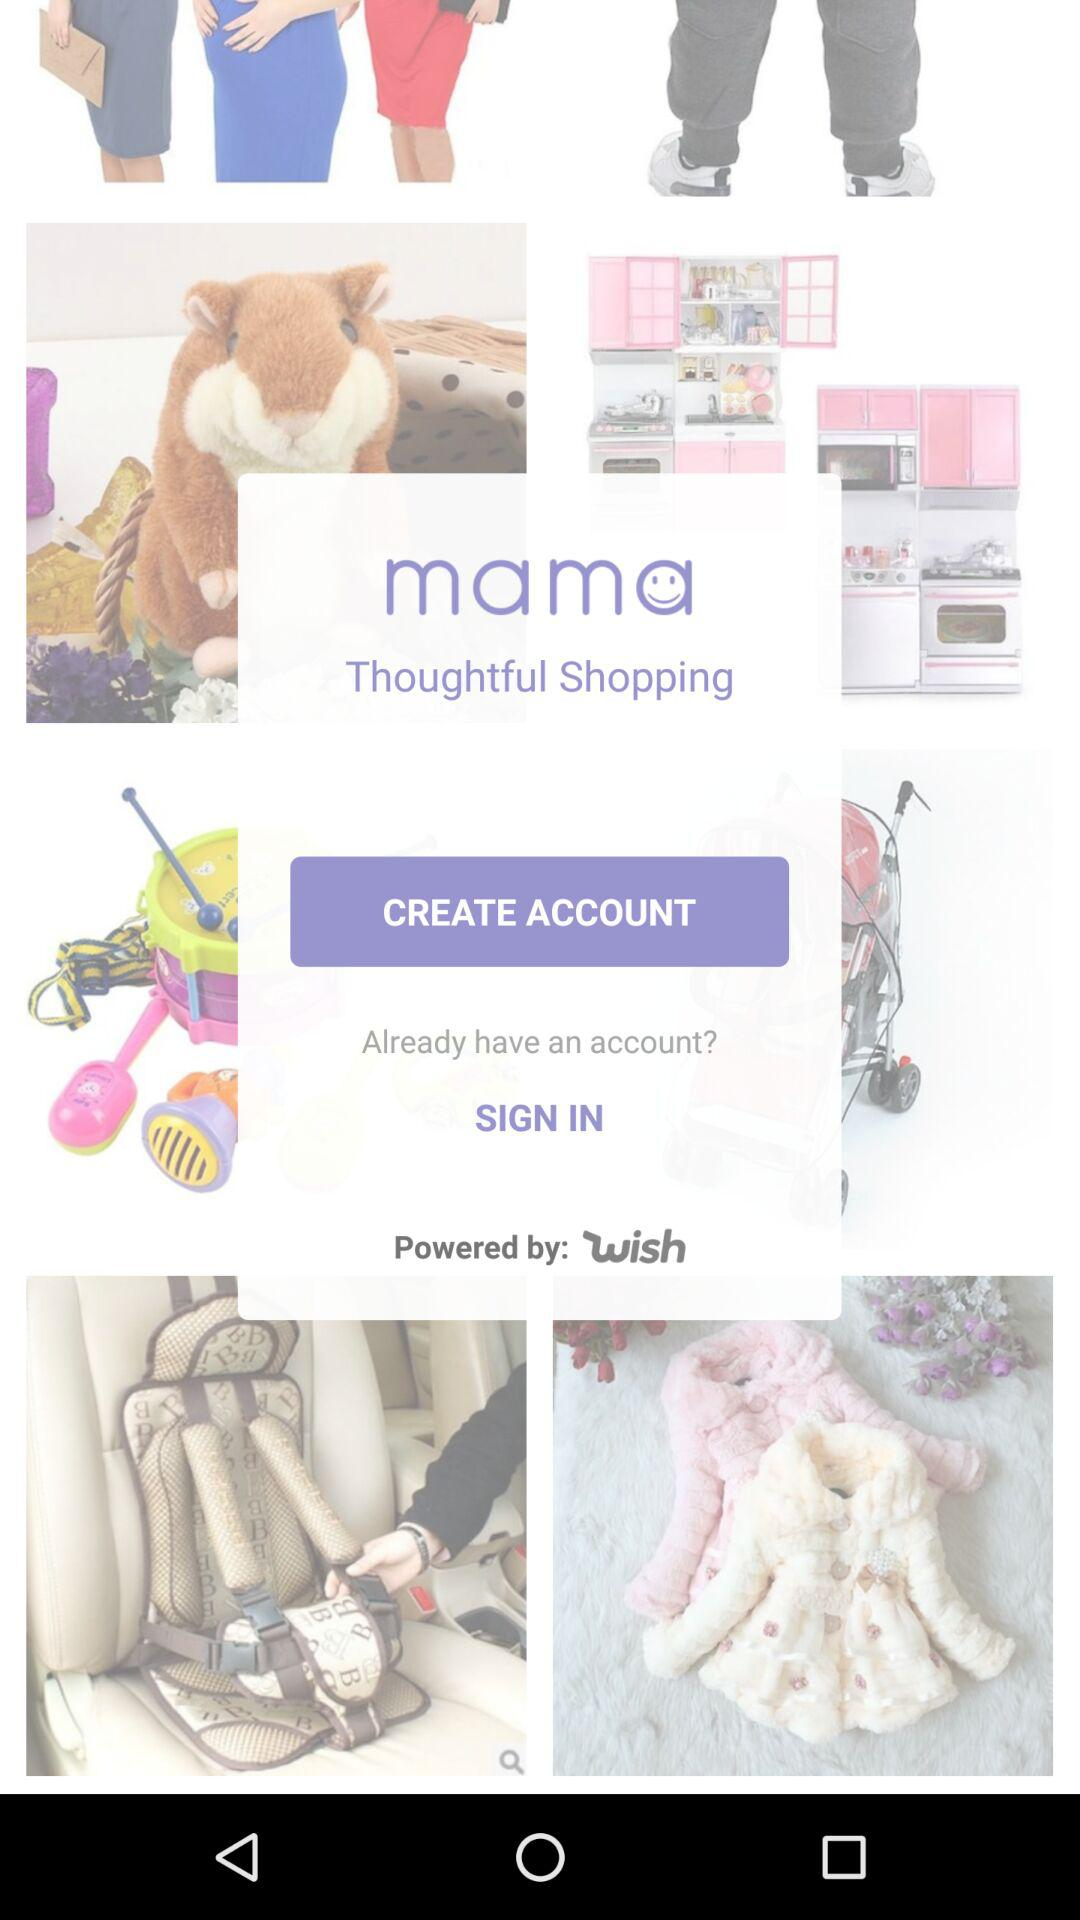What is the name of the application? The name of the application is "mama Thoughtful Shopping". 